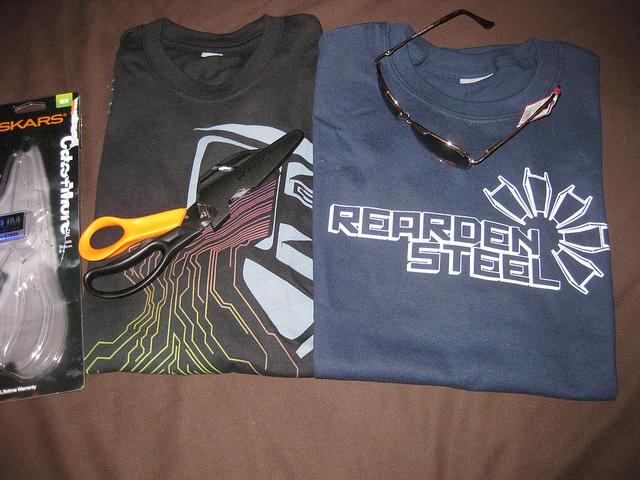What was in the opened package?
Concise answer only. Scissors. What does the cloth on the right read?
Concise answer only. Rearden steel. Is the person who took this picture showing off?
Write a very short answer. No. 